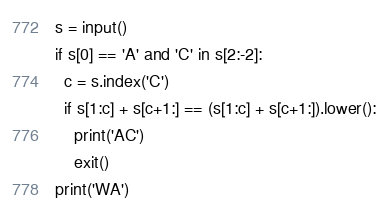<code> <loc_0><loc_0><loc_500><loc_500><_Python_>s = input()
if s[0] == 'A' and 'C' in s[2:-2]:
  c = s.index('C')
  if s[1:c] + s[c+1:] == (s[1:c] + s[c+1:]).lower():
    print('AC')
    exit()
print('WA')</code> 